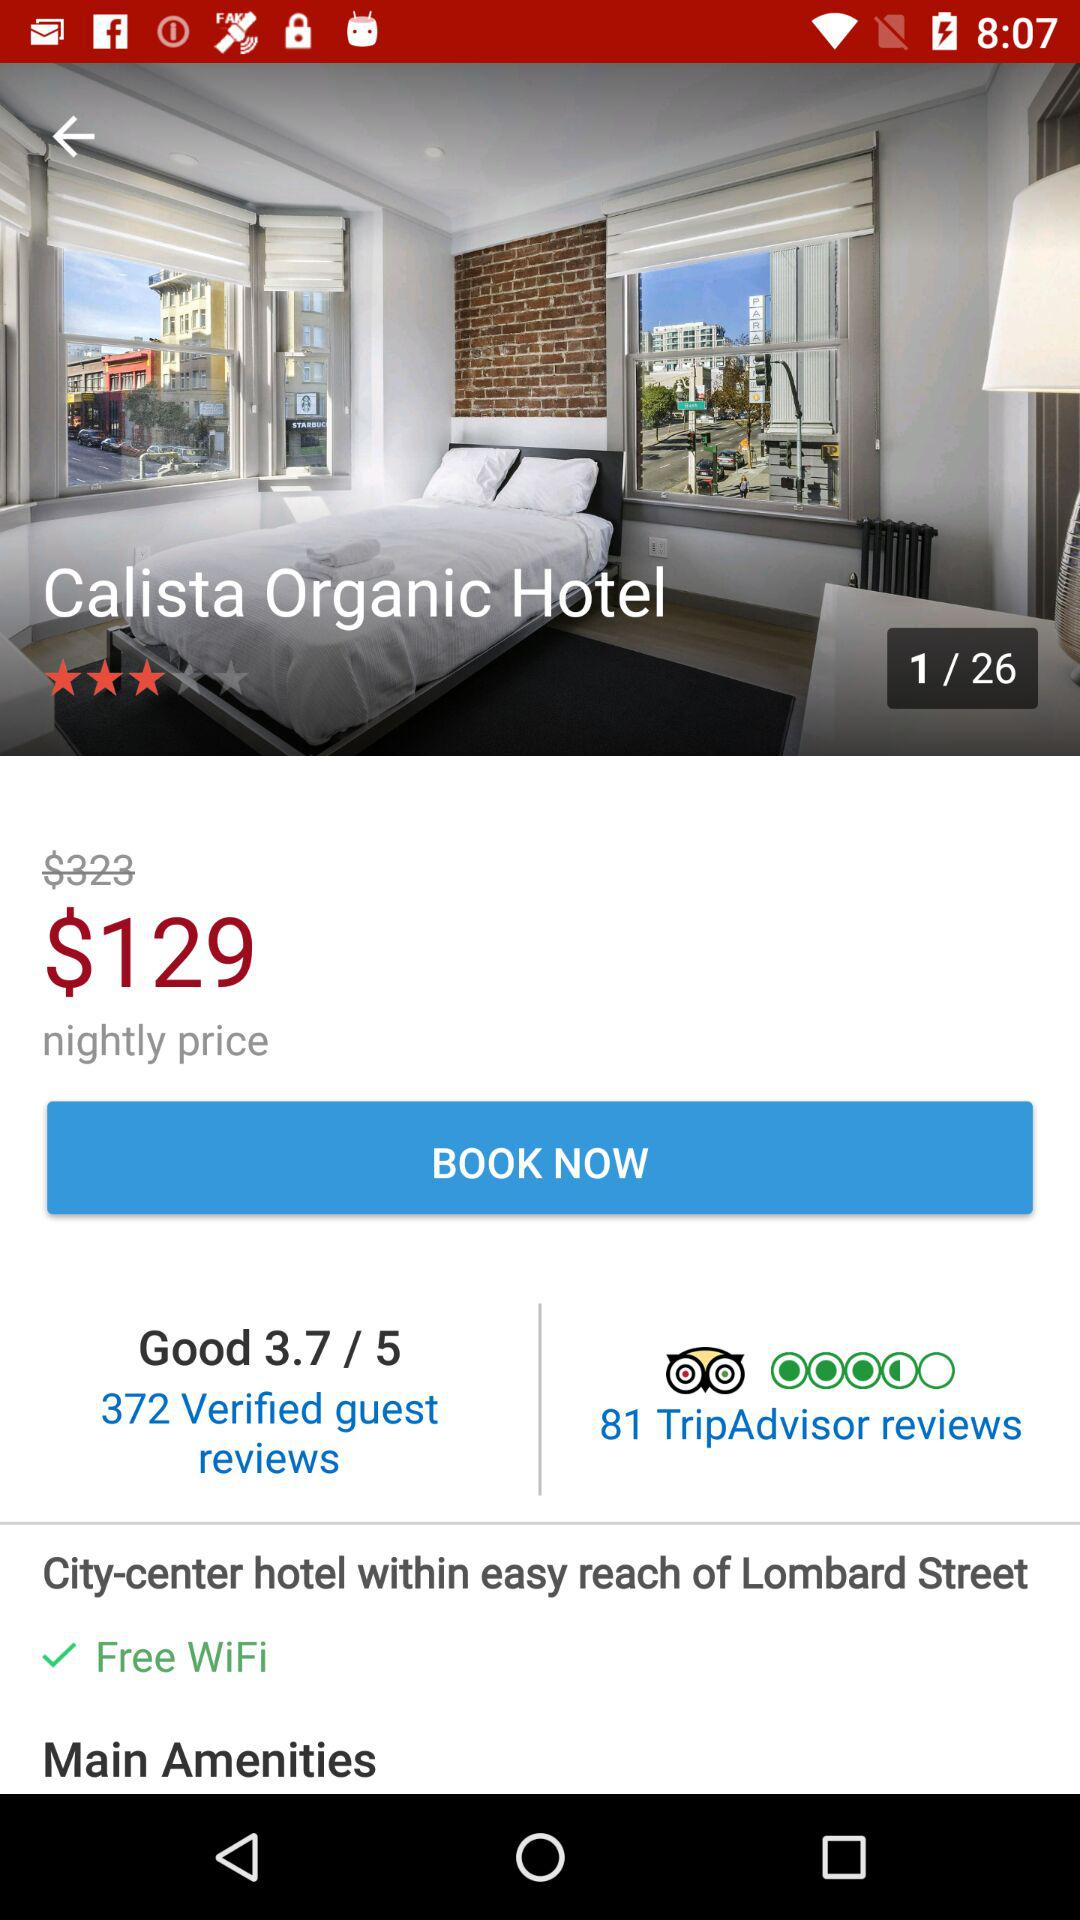What is the total number of pages? The total number of pages is 26. 